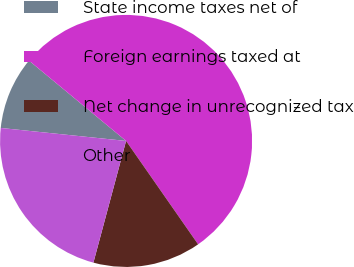<chart> <loc_0><loc_0><loc_500><loc_500><pie_chart><fcel>State income taxes net of<fcel>Foreign earnings taxed at<fcel>Net change in unrecognized tax<fcel>Other<nl><fcel>9.36%<fcel>54.31%<fcel>13.86%<fcel>22.47%<nl></chart> 